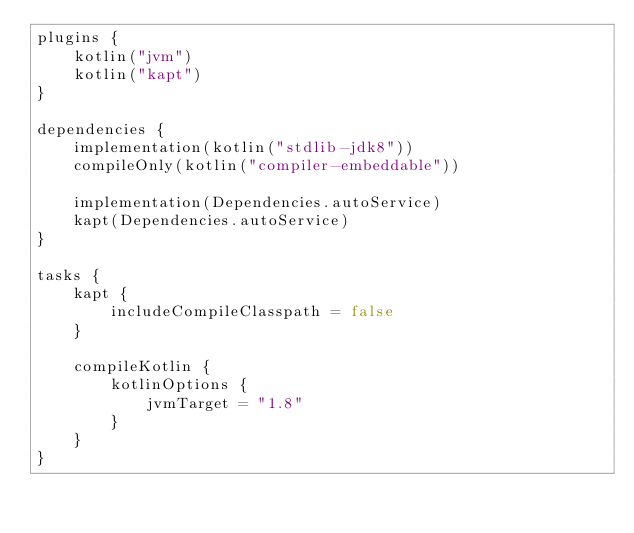<code> <loc_0><loc_0><loc_500><loc_500><_Kotlin_>plugins {
    kotlin("jvm")
    kotlin("kapt")
}

dependencies {
    implementation(kotlin("stdlib-jdk8"))
    compileOnly(kotlin("compiler-embeddable"))

    implementation(Dependencies.autoService)
    kapt(Dependencies.autoService)
}

tasks {
    kapt {
        includeCompileClasspath = false
    }

    compileKotlin {
        kotlinOptions {
            jvmTarget = "1.8"
        }
    }
}
</code> 